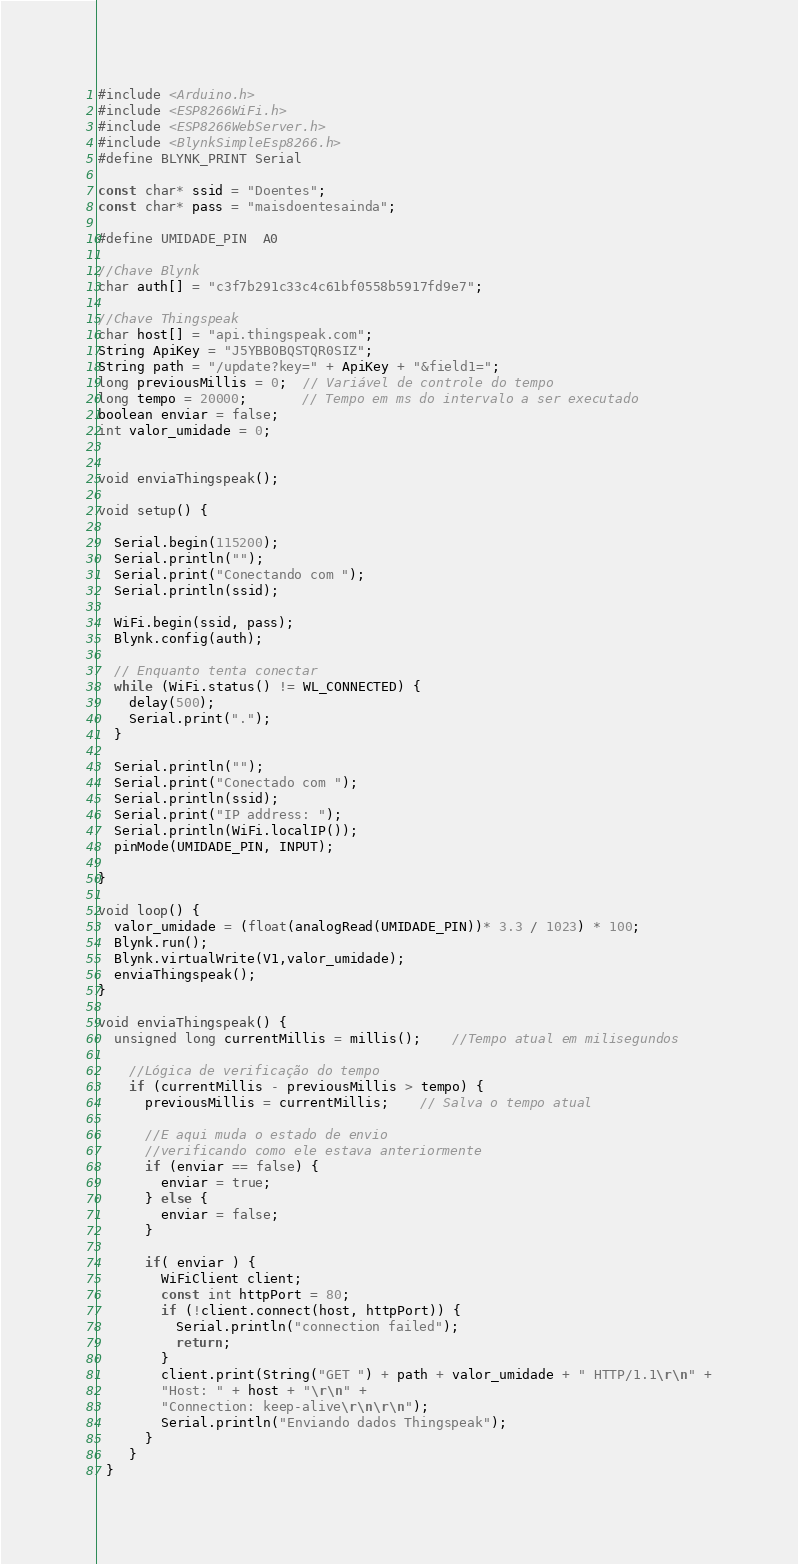Convert code to text. <code><loc_0><loc_0><loc_500><loc_500><_C++_>#include <Arduino.h>
#include <ESP8266WiFi.h>
#include <ESP8266WebServer.h>
#include <BlynkSimpleEsp8266.h>
#define BLYNK_PRINT Serial

const char* ssid = "Doentes";
const char* pass = "maisdoentesainda";

#define UMIDADE_PIN  A0

//Chave Blynk
char auth[] = "c3f7b291c33c4c61bf0558b5917fd9e7";

//Chave Thingspeak
char host[] = "api.thingspeak.com";
String ApiKey = "J5YBBOBQSTQR0SIZ";
String path = "/update?key=" + ApiKey + "&field1=";
long previousMillis = 0;  // Variável de controle do tempo
long tempo = 20000;       // Tempo em ms do intervalo a ser executado
boolean enviar = false;
int valor_umidade = 0;


void enviaThingspeak();

void setup() {

  Serial.begin(115200);
  Serial.println("");
  Serial.print("Conectando com ");
  Serial.println(ssid);

  WiFi.begin(ssid, pass);
  Blynk.config(auth);

  // Enquanto tenta conectar
  while (WiFi.status() != WL_CONNECTED) {
    delay(500);
    Serial.print(".");
  }

  Serial.println("");
  Serial.print("Conectado com ");
  Serial.println(ssid);
  Serial.print("IP address: ");
  Serial.println(WiFi.localIP());
  pinMode(UMIDADE_PIN, INPUT);

}

void loop() {
  valor_umidade = (float(analogRead(UMIDADE_PIN))* 3.3 / 1023) * 100;
  Blynk.run();
  Blynk.virtualWrite(V1,valor_umidade);
  enviaThingspeak();
}

void enviaThingspeak() {
  unsigned long currentMillis = millis();    //Tempo atual em milisegundos

    //Lógica de verificação do tempo
    if (currentMillis - previousMillis > tempo) {
      previousMillis = currentMillis;    // Salva o tempo atual

      //E aqui muda o estado de envio
      //verificando como ele estava anteriormente
      if (enviar == false) {
        enviar = true;
      } else {
        enviar = false;
      }

      if( enviar ) {
        WiFiClient client;
        const int httpPort = 80;
        if (!client.connect(host, httpPort)) {
          Serial.println("connection failed");
          return;
        }
        client.print(String("GET ") + path + valor_umidade + " HTTP/1.1\r\n" +
        "Host: " + host + "\r\n" +
        "Connection: keep-alive\r\n\r\n");
        Serial.println("Enviando dados Thingspeak");
      }
    }
 }
</code> 